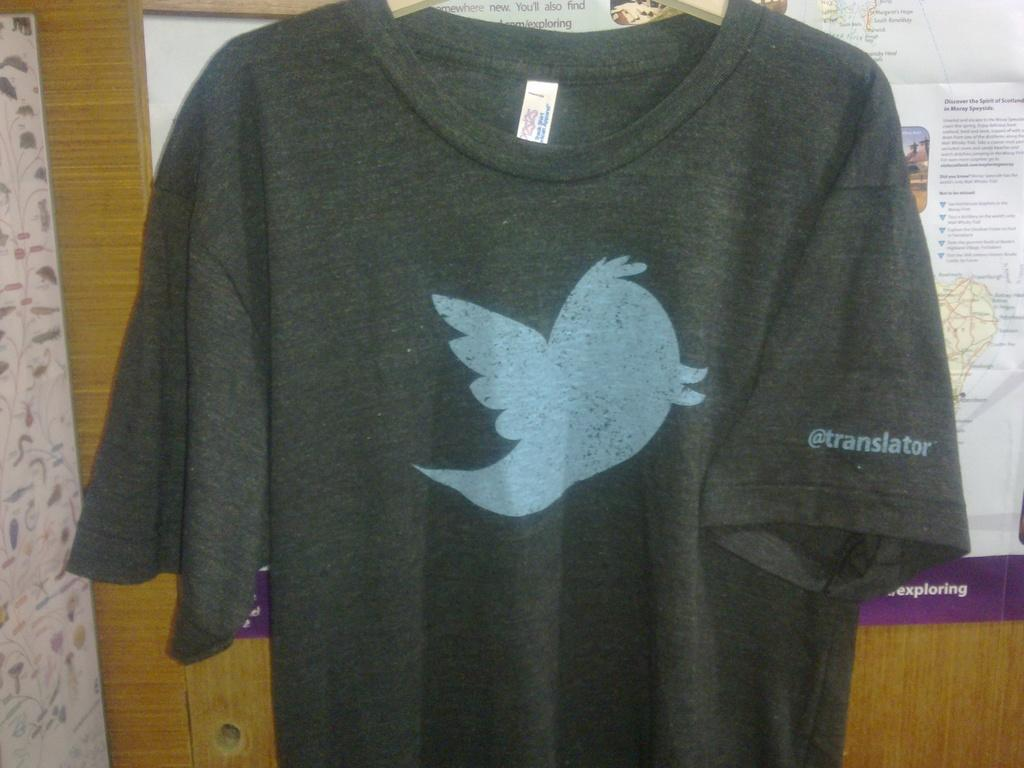What type of clothing item is in the image? There is a t-shirt in the image. What can be seen on the t-shirt? The t-shirt has a design and text. What is visible in the background of the image? There are posters in the background of the image. Can you tell me how many mountains are visible in the image? There are no mountains visible in the image; it features a t-shirt with a design and text, as well as posters in the background. 